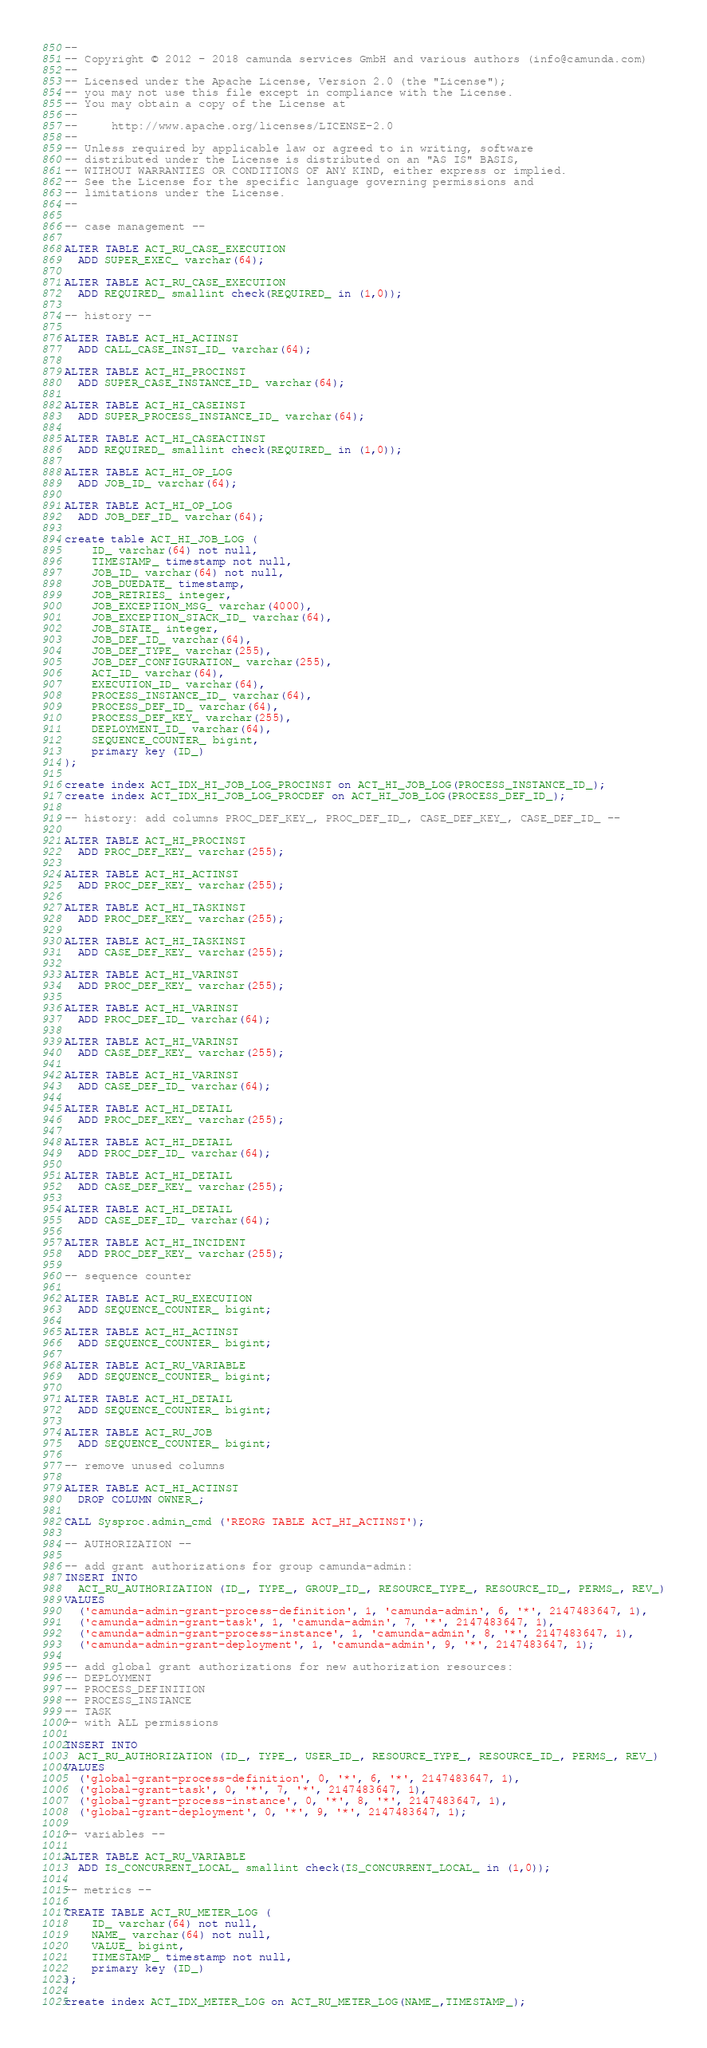Convert code to text. <code><loc_0><loc_0><loc_500><loc_500><_SQL_>--
-- Copyright © 2012 - 2018 camunda services GmbH and various authors (info@camunda.com)
--
-- Licensed under the Apache License, Version 2.0 (the "License");
-- you may not use this file except in compliance with the License.
-- You may obtain a copy of the License at
--
--     http://www.apache.org/licenses/LICENSE-2.0
--
-- Unless required by applicable law or agreed to in writing, software
-- distributed under the License is distributed on an "AS IS" BASIS,
-- WITHOUT WARRANTIES OR CONDITIONS OF ANY KIND, either express or implied.
-- See the License for the specific language governing permissions and
-- limitations under the License.
--

-- case management --

ALTER TABLE ACT_RU_CASE_EXECUTION
  ADD SUPER_EXEC_ varchar(64);

ALTER TABLE ACT_RU_CASE_EXECUTION
  ADD REQUIRED_ smallint check(REQUIRED_ in (1,0));

-- history --

ALTER TABLE ACT_HI_ACTINST
  ADD CALL_CASE_INST_ID_ varchar(64);

ALTER TABLE ACT_HI_PROCINST
  ADD SUPER_CASE_INSTANCE_ID_ varchar(64);

ALTER TABLE ACT_HI_CASEINST
  ADD SUPER_PROCESS_INSTANCE_ID_ varchar(64);

ALTER TABLE ACT_HI_CASEACTINST
  ADD REQUIRED_ smallint check(REQUIRED_ in (1,0));

ALTER TABLE ACT_HI_OP_LOG
  ADD JOB_ID_ varchar(64);

ALTER TABLE ACT_HI_OP_LOG
  ADD JOB_DEF_ID_ varchar(64);

create table ACT_HI_JOB_LOG (
    ID_ varchar(64) not null,
    TIMESTAMP_ timestamp not null,
    JOB_ID_ varchar(64) not null,
    JOB_DUEDATE_ timestamp,
    JOB_RETRIES_ integer,
    JOB_EXCEPTION_MSG_ varchar(4000),
    JOB_EXCEPTION_STACK_ID_ varchar(64),
    JOB_STATE_ integer,
    JOB_DEF_ID_ varchar(64),
    JOB_DEF_TYPE_ varchar(255),
    JOB_DEF_CONFIGURATION_ varchar(255),
    ACT_ID_ varchar(64),
    EXECUTION_ID_ varchar(64),
    PROCESS_INSTANCE_ID_ varchar(64),
    PROCESS_DEF_ID_ varchar(64),
    PROCESS_DEF_KEY_ varchar(255),
    DEPLOYMENT_ID_ varchar(64),
    SEQUENCE_COUNTER_ bigint,
    primary key (ID_)
);

create index ACT_IDX_HI_JOB_LOG_PROCINST on ACT_HI_JOB_LOG(PROCESS_INSTANCE_ID_);
create index ACT_IDX_HI_JOB_LOG_PROCDEF on ACT_HI_JOB_LOG(PROCESS_DEF_ID_);

-- history: add columns PROC_DEF_KEY_, PROC_DEF_ID_, CASE_DEF_KEY_, CASE_DEF_ID_ --

ALTER TABLE ACT_HI_PROCINST
  ADD PROC_DEF_KEY_ varchar(255);

ALTER TABLE ACT_HI_ACTINST
  ADD PROC_DEF_KEY_ varchar(255);

ALTER TABLE ACT_HI_TASKINST
  ADD PROC_DEF_KEY_ varchar(255);

ALTER TABLE ACT_HI_TASKINST
  ADD CASE_DEF_KEY_ varchar(255);

ALTER TABLE ACT_HI_VARINST
  ADD PROC_DEF_KEY_ varchar(255);

ALTER TABLE ACT_HI_VARINST
  ADD PROC_DEF_ID_ varchar(64);

ALTER TABLE ACT_HI_VARINST
  ADD CASE_DEF_KEY_ varchar(255);

ALTER TABLE ACT_HI_VARINST
  ADD CASE_DEF_ID_ varchar(64);

ALTER TABLE ACT_HI_DETAIL
  ADD PROC_DEF_KEY_ varchar(255);

ALTER TABLE ACT_HI_DETAIL
  ADD PROC_DEF_ID_ varchar(64);

ALTER TABLE ACT_HI_DETAIL
  ADD CASE_DEF_KEY_ varchar(255);

ALTER TABLE ACT_HI_DETAIL
  ADD CASE_DEF_ID_ varchar(64);

ALTER TABLE ACT_HI_INCIDENT
  ADD PROC_DEF_KEY_ varchar(255);

-- sequence counter

ALTER TABLE ACT_RU_EXECUTION
  ADD SEQUENCE_COUNTER_ bigint;

ALTER TABLE ACT_HI_ACTINST
  ADD SEQUENCE_COUNTER_ bigint;

ALTER TABLE ACT_RU_VARIABLE
  ADD SEQUENCE_COUNTER_ bigint;

ALTER TABLE ACT_HI_DETAIL
  ADD SEQUENCE_COUNTER_ bigint;

ALTER TABLE ACT_RU_JOB
  ADD SEQUENCE_COUNTER_ bigint;

-- remove unused columns

ALTER TABLE ACT_HI_ACTINST
  DROP COLUMN OWNER_;

CALL Sysproc.admin_cmd ('REORG TABLE ACT_HI_ACTINST');

-- AUTHORIZATION --

-- add grant authorizations for group camunda-admin:
INSERT INTO
  ACT_RU_AUTHORIZATION (ID_, TYPE_, GROUP_ID_, RESOURCE_TYPE_, RESOURCE_ID_, PERMS_, REV_)
VALUES
  ('camunda-admin-grant-process-definition', 1, 'camunda-admin', 6, '*', 2147483647, 1),
  ('camunda-admin-grant-task', 1, 'camunda-admin', 7, '*', 2147483647, 1),
  ('camunda-admin-grant-process-instance', 1, 'camunda-admin', 8, '*', 2147483647, 1),
  ('camunda-admin-grant-deployment', 1, 'camunda-admin', 9, '*', 2147483647, 1);

-- add global grant authorizations for new authorization resources:
-- DEPLOYMENT
-- PROCESS_DEFINITION
-- PROCESS_INSTANCE
-- TASK
-- with ALL permissions

INSERT INTO
  ACT_RU_AUTHORIZATION (ID_, TYPE_, USER_ID_, RESOURCE_TYPE_, RESOURCE_ID_, PERMS_, REV_)
VALUES
  ('global-grant-process-definition', 0, '*', 6, '*', 2147483647, 1),
  ('global-grant-task', 0, '*', 7, '*', 2147483647, 1),
  ('global-grant-process-instance', 0, '*', 8, '*', 2147483647, 1),
  ('global-grant-deployment', 0, '*', 9, '*', 2147483647, 1);

-- variables --

ALTER TABLE ACT_RU_VARIABLE
  ADD IS_CONCURRENT_LOCAL_ smallint check(IS_CONCURRENT_LOCAL_ in (1,0));

-- metrics --

CREATE TABLE ACT_RU_METER_LOG (
    ID_ varchar(64) not null,
    NAME_ varchar(64) not null,
    VALUE_ bigint,
    TIMESTAMP_ timestamp not null,
    primary key (ID_)
);

create index ACT_IDX_METER_LOG on ACT_RU_METER_LOG(NAME_,TIMESTAMP_);
</code> 